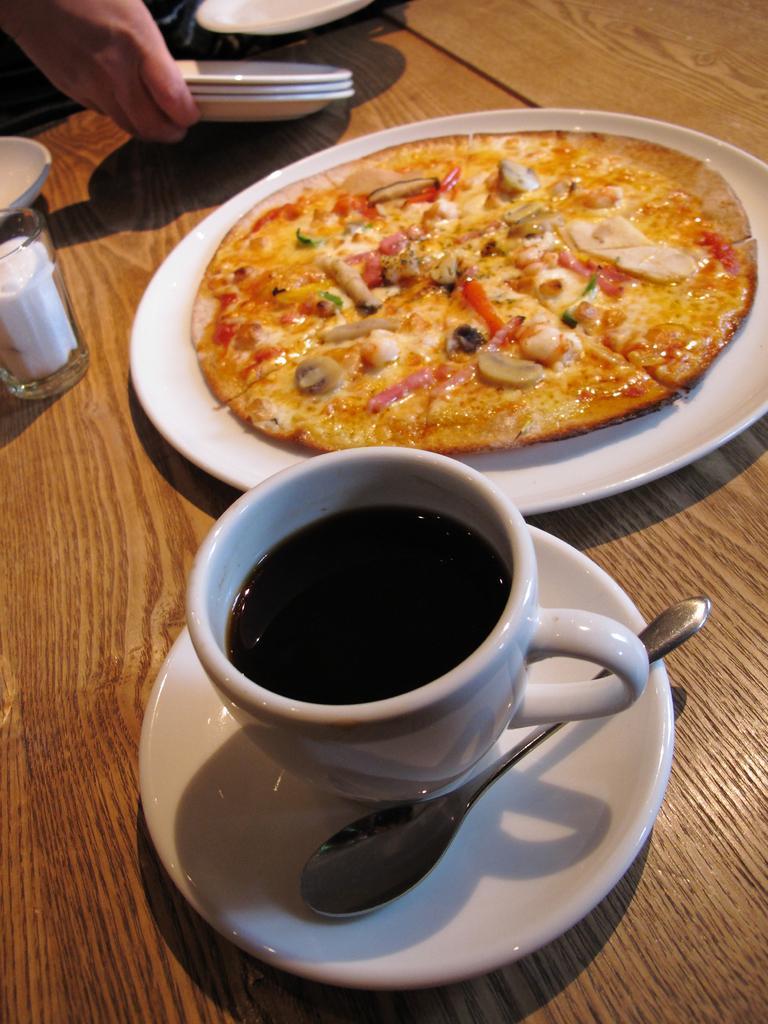How would you summarize this image in a sentence or two? In this picture we can see a pizza in the plate, beside to the plate we can find a cup and a spoon in the saucer, and also we can find a glass on the table. 